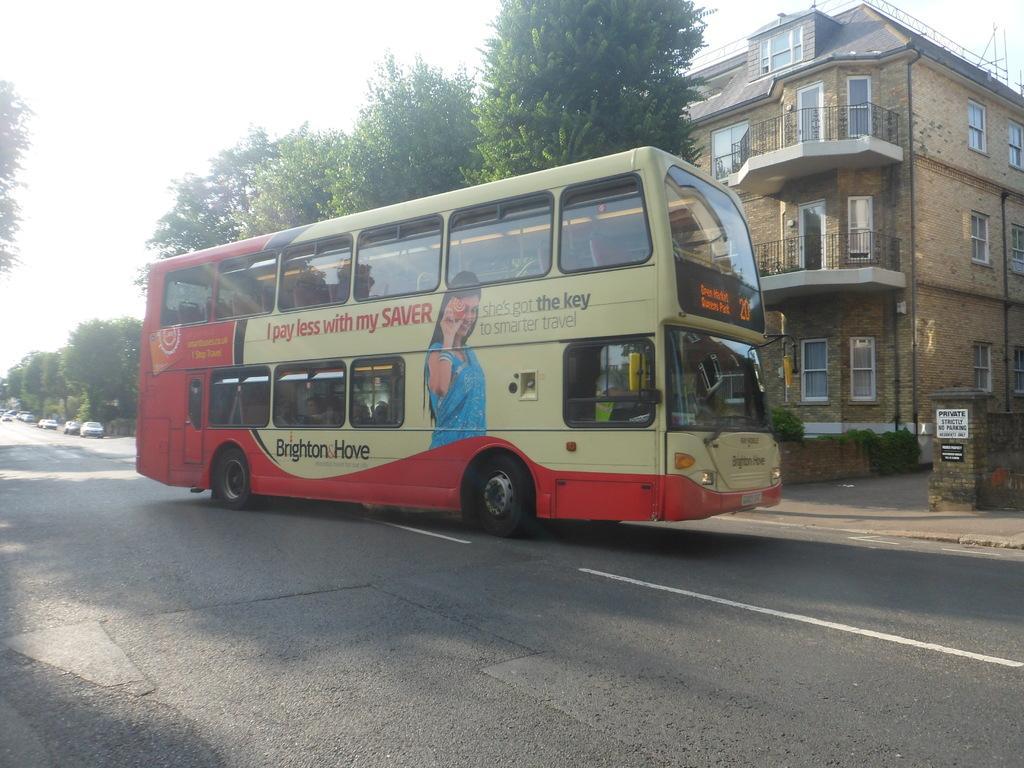Please provide a concise description of this image. In this image there is a double decker bus on the road. In the background there is a building, Beside the building there are trees. On the road there are cars. 